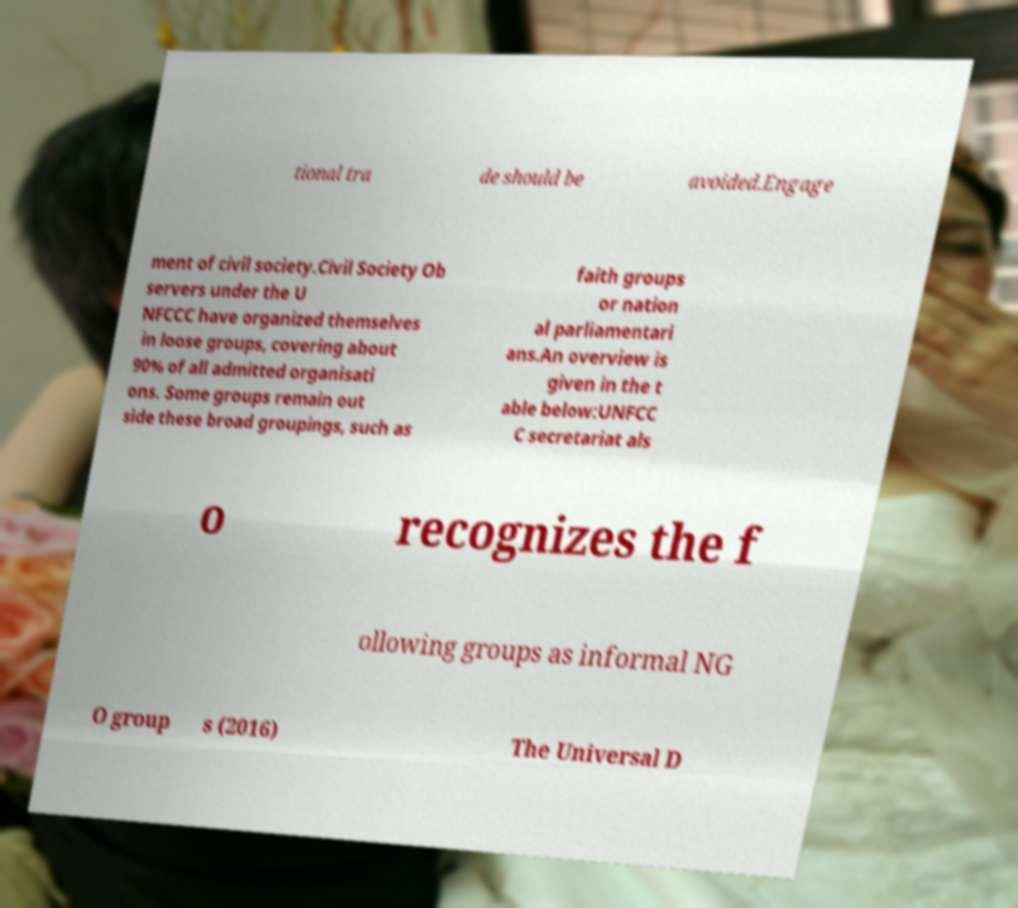Can you read and provide the text displayed in the image?This photo seems to have some interesting text. Can you extract and type it out for me? tional tra de should be avoided.Engage ment of civil society.Civil Society Ob servers under the U NFCCC have organized themselves in loose groups, covering about 90% of all admitted organisati ons. Some groups remain out side these broad groupings, such as faith groups or nation al parliamentari ans.An overview is given in the t able below:UNFCC C secretariat als o recognizes the f ollowing groups as informal NG O group s (2016) The Universal D 